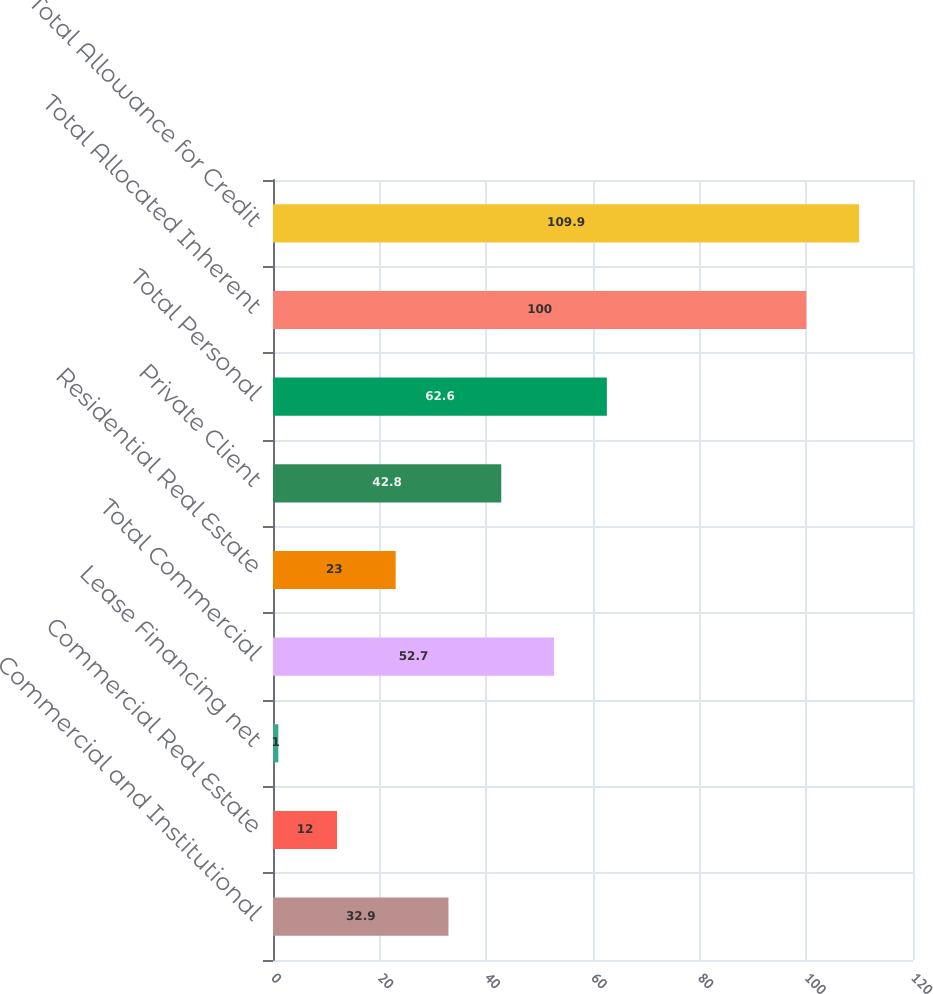Convert chart. <chart><loc_0><loc_0><loc_500><loc_500><bar_chart><fcel>Commercial and Institutional<fcel>Commercial Real Estate<fcel>Lease Financing net<fcel>Total Commercial<fcel>Residential Real Estate<fcel>Private Client<fcel>Total Personal<fcel>Total Allocated Inherent<fcel>Total Allowance for Credit<nl><fcel>32.9<fcel>12<fcel>1<fcel>52.7<fcel>23<fcel>42.8<fcel>62.6<fcel>100<fcel>109.9<nl></chart> 